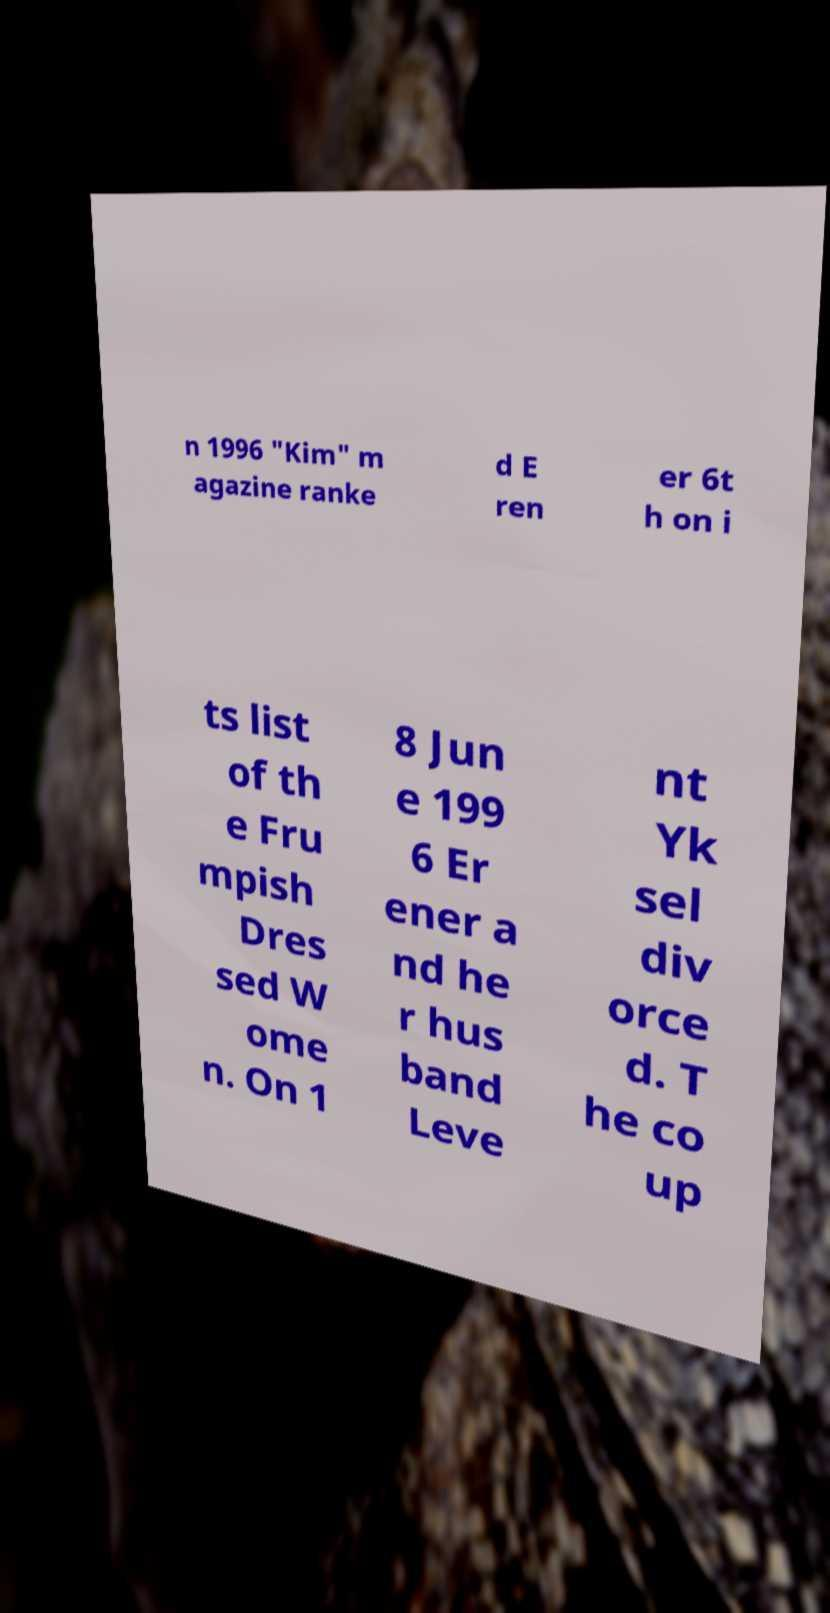Could you assist in decoding the text presented in this image and type it out clearly? n 1996 "Kim" m agazine ranke d E ren er 6t h on i ts list of th e Fru mpish Dres sed W ome n. On 1 8 Jun e 199 6 Er ener a nd he r hus band Leve nt Yk sel div orce d. T he co up 